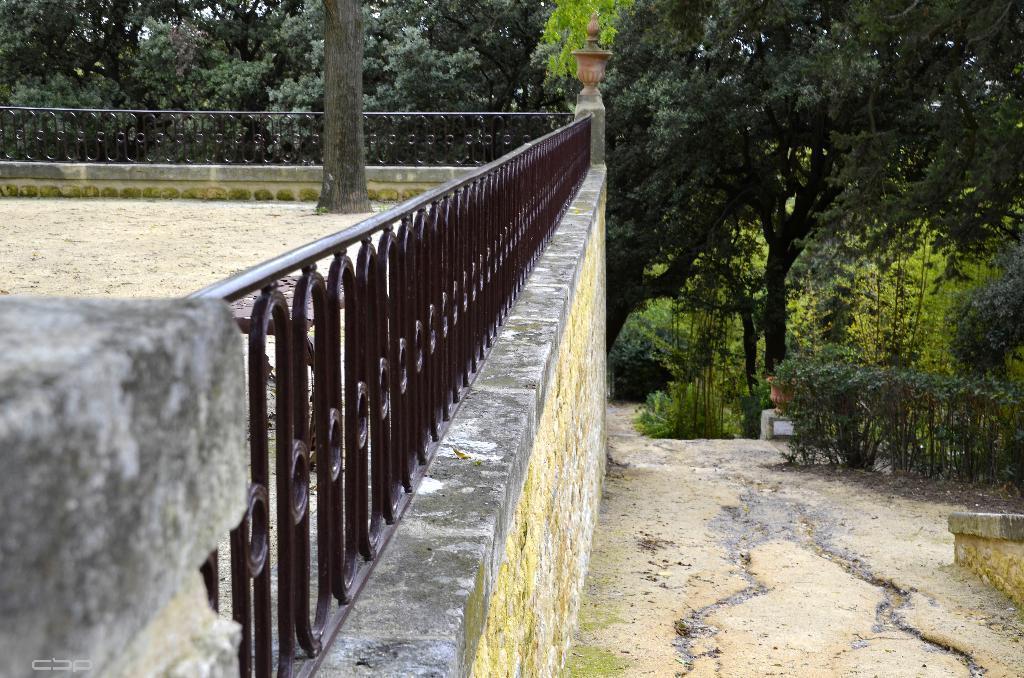In one or two sentences, can you explain what this image depicts? On the left side of the image we can see wall, fencing, sand and tree. In the background we can see plants and trees. 